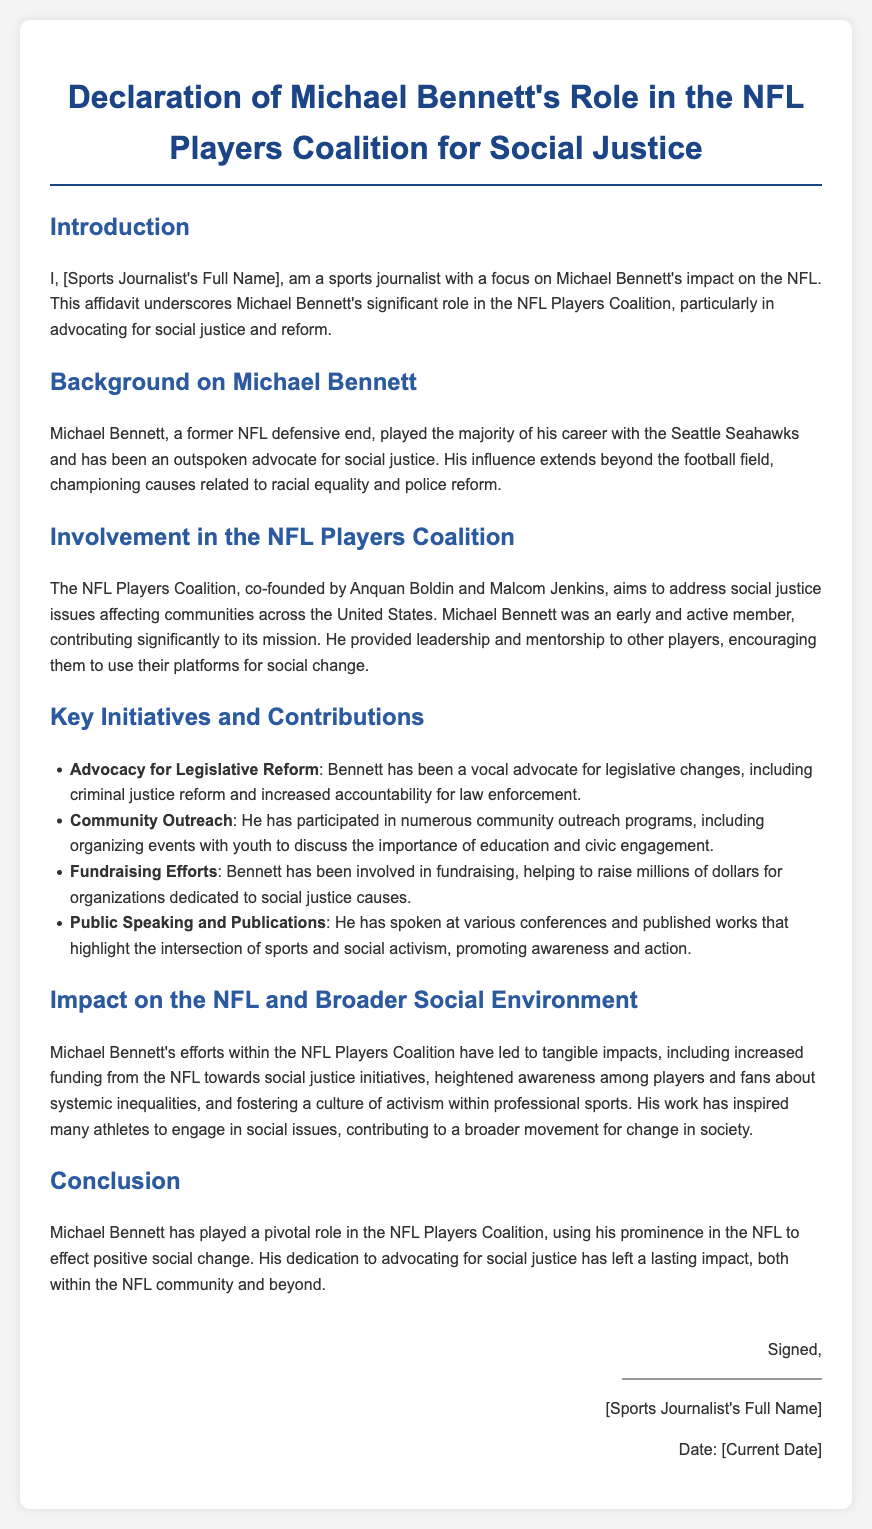What is the main role of Michael Bennett in the NFL Players Coalition? The document states that Michael Bennett's significant role is advocating for social justice and reform within the NFL Players Coalition.
Answer: advocating for social justice Who co-founded the NFL Players Coalition? The document mentions that Anquan Boldin and Malcom Jenkins co-founded the NFL Players Coalition.
Answer: Anquan Boldin and Malcom Jenkins What is one of the key initiatives led by Michael Bennett? The document lists several key initiatives, one being the advocacy for legislative reform.
Answer: advocacy for legislative reform How has Michael Bennett contributed to fundraising efforts? The document states that Michael Bennett has helped raise millions of dollars for organizations dedicated to social justice causes.
Answer: millions of dollars What impact has Michael Bennett's work had on the awareness of players? According to the document, Michael Bennett's efforts have heightened awareness among players about systemic inequalities.
Answer: heightened awareness What type of outreach programs has Michael Bennett participated in? The document mentions that he has participated in community outreach programs, particularly with youth.
Answer: community outreach programs In what year was this declaration likely written? The document references that it was signed with the notation "Date: [Current Date]," suggesting it was written in the current year.
Answer: current year What is the purpose of this affidavit? The document's purpose is outlined as underscoring Michael Bennett's significant role in advocating for social justice and reform in the NFL.
Answer: underscore Michael Bennett's role Who is the author of the declaration? The declaration states it is authored by "[Sports Journalist's Full Name]."
Answer: [Sports Journalist's Full Name] 